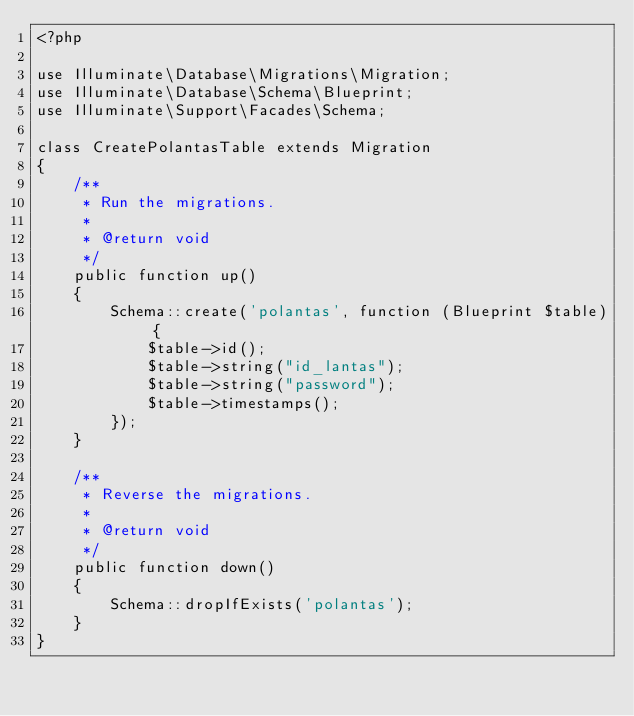Convert code to text. <code><loc_0><loc_0><loc_500><loc_500><_PHP_><?php

use Illuminate\Database\Migrations\Migration;
use Illuminate\Database\Schema\Blueprint;
use Illuminate\Support\Facades\Schema;

class CreatePolantasTable extends Migration
{
    /**
     * Run the migrations.
     *
     * @return void
     */
    public function up()
    {
        Schema::create('polantas', function (Blueprint $table) {
            $table->id();
            $table->string("id_lantas");
            $table->string("password");
            $table->timestamps();
        });
    }

    /**
     * Reverse the migrations.
     *
     * @return void
     */
    public function down()
    {
        Schema::dropIfExists('polantas');
    }
}
</code> 